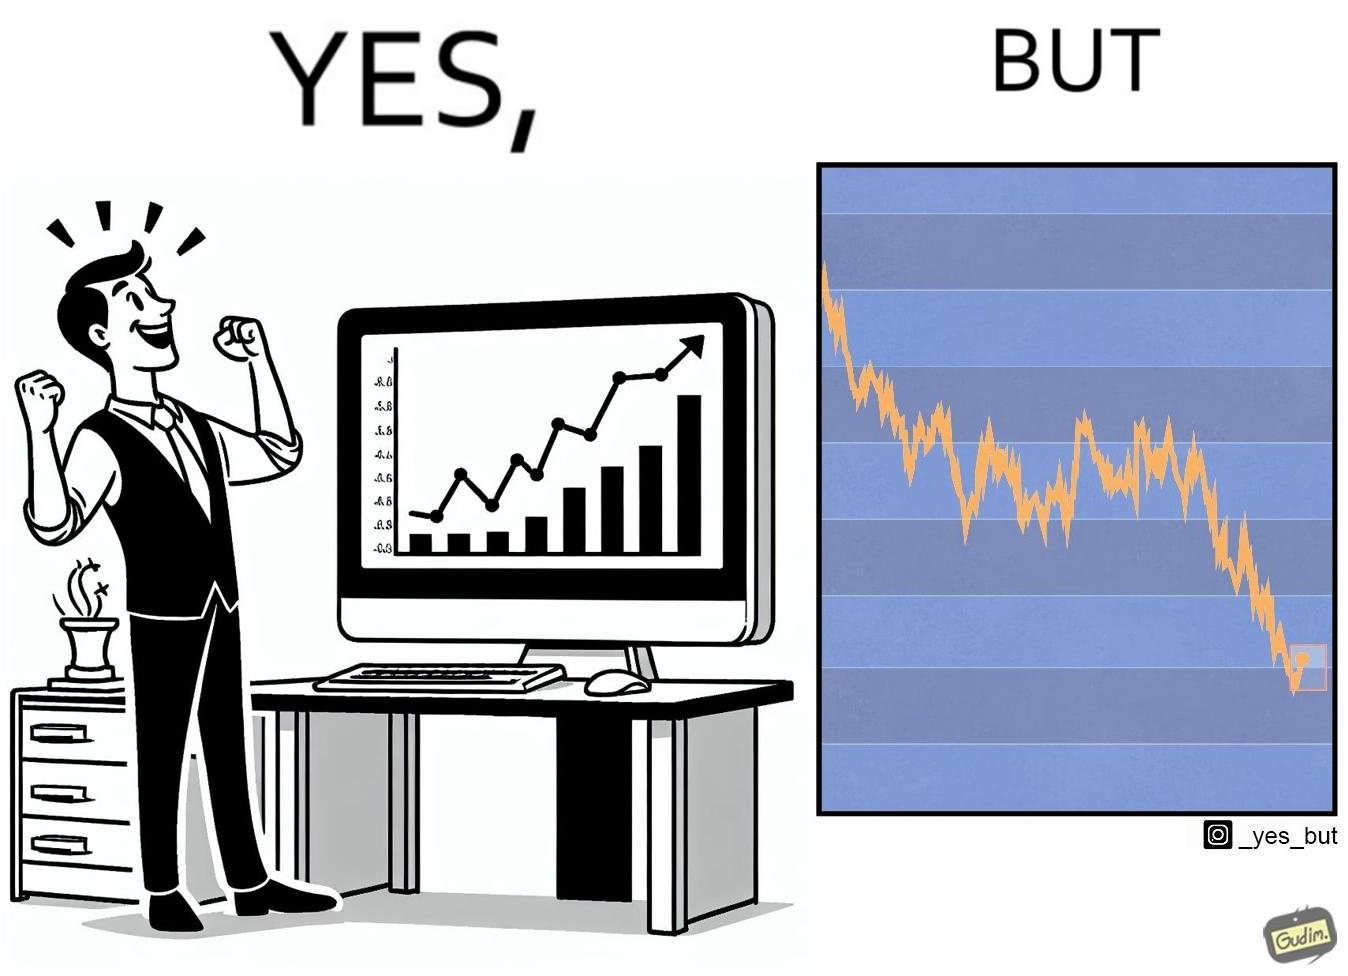What is the satirical meaning behind this image? The image is ironic, because a person is seen feeling proud over the profit earned over his investment but the right image shows the whole story how only a small part of his investment journey is shown and the other loss part is ignored 